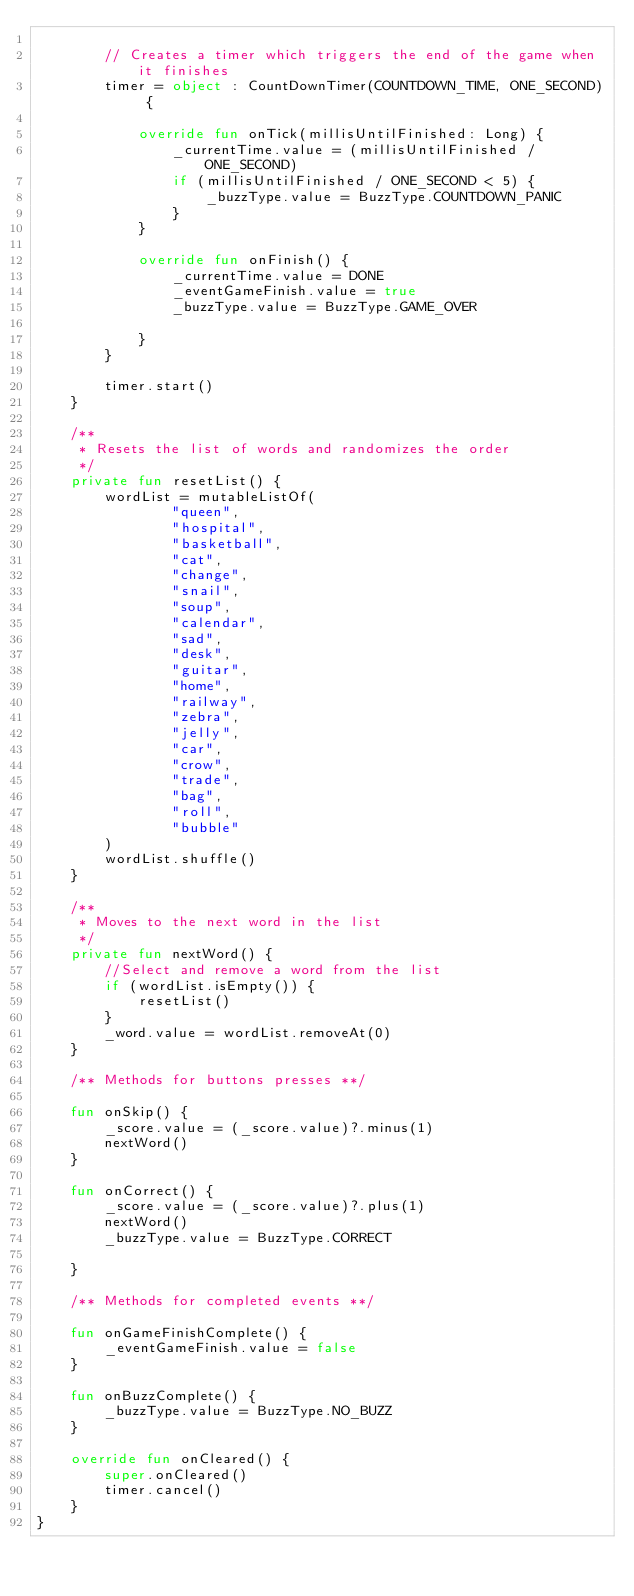Convert code to text. <code><loc_0><loc_0><loc_500><loc_500><_Kotlin_>
        // Creates a timer which triggers the end of the game when it finishes
        timer = object : CountDownTimer(COUNTDOWN_TIME, ONE_SECOND) {

            override fun onTick(millisUntilFinished: Long) {
                _currentTime.value = (millisUntilFinished / ONE_SECOND)
                if (millisUntilFinished / ONE_SECOND < 5) {
                    _buzzType.value = BuzzType.COUNTDOWN_PANIC
                }
            }

            override fun onFinish() {
                _currentTime.value = DONE
                _eventGameFinish.value = true
                _buzzType.value = BuzzType.GAME_OVER

            }
        }

        timer.start()
    }

    /**
     * Resets the list of words and randomizes the order
     */
    private fun resetList() {
        wordList = mutableListOf(
                "queen",
                "hospital",
                "basketball",
                "cat",
                "change",
                "snail",
                "soup",
                "calendar",
                "sad",
                "desk",
                "guitar",
                "home",
                "railway",
                "zebra",
                "jelly",
                "car",
                "crow",
                "trade",
                "bag",
                "roll",
                "bubble"
        )
        wordList.shuffle()
    }

    /**
     * Moves to the next word in the list
     */
    private fun nextWord() {
        //Select and remove a word from the list
        if (wordList.isEmpty()) {
            resetList()
        }
        _word.value = wordList.removeAt(0)
    }

    /** Methods for buttons presses **/

    fun onSkip() {
        _score.value = (_score.value)?.minus(1)
        nextWord()
    }

    fun onCorrect() {
        _score.value = (_score.value)?.plus(1)
        nextWord()
        _buzzType.value = BuzzType.CORRECT

    }

    /** Methods for completed events **/

    fun onGameFinishComplete() {
        _eventGameFinish.value = false
    }

    fun onBuzzComplete() {
        _buzzType.value = BuzzType.NO_BUZZ
    }

    override fun onCleared() {
        super.onCleared()
        timer.cancel()
    }
}
</code> 